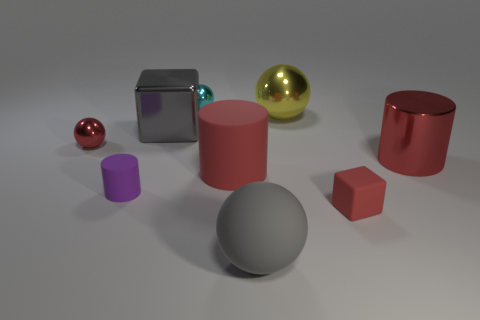Subtract all red cylinders. How many cylinders are left? 1 Subtract all purple cylinders. How many cylinders are left? 2 Subtract 0 blue cubes. How many objects are left? 9 Subtract all cubes. How many objects are left? 7 Subtract 2 blocks. How many blocks are left? 0 Subtract all green cubes. Subtract all green balls. How many cubes are left? 2 Subtract all blue balls. How many purple cylinders are left? 1 Subtract all small red metal things. Subtract all gray shiny blocks. How many objects are left? 7 Add 3 metallic cubes. How many metallic cubes are left? 4 Add 5 large red things. How many large red things exist? 7 